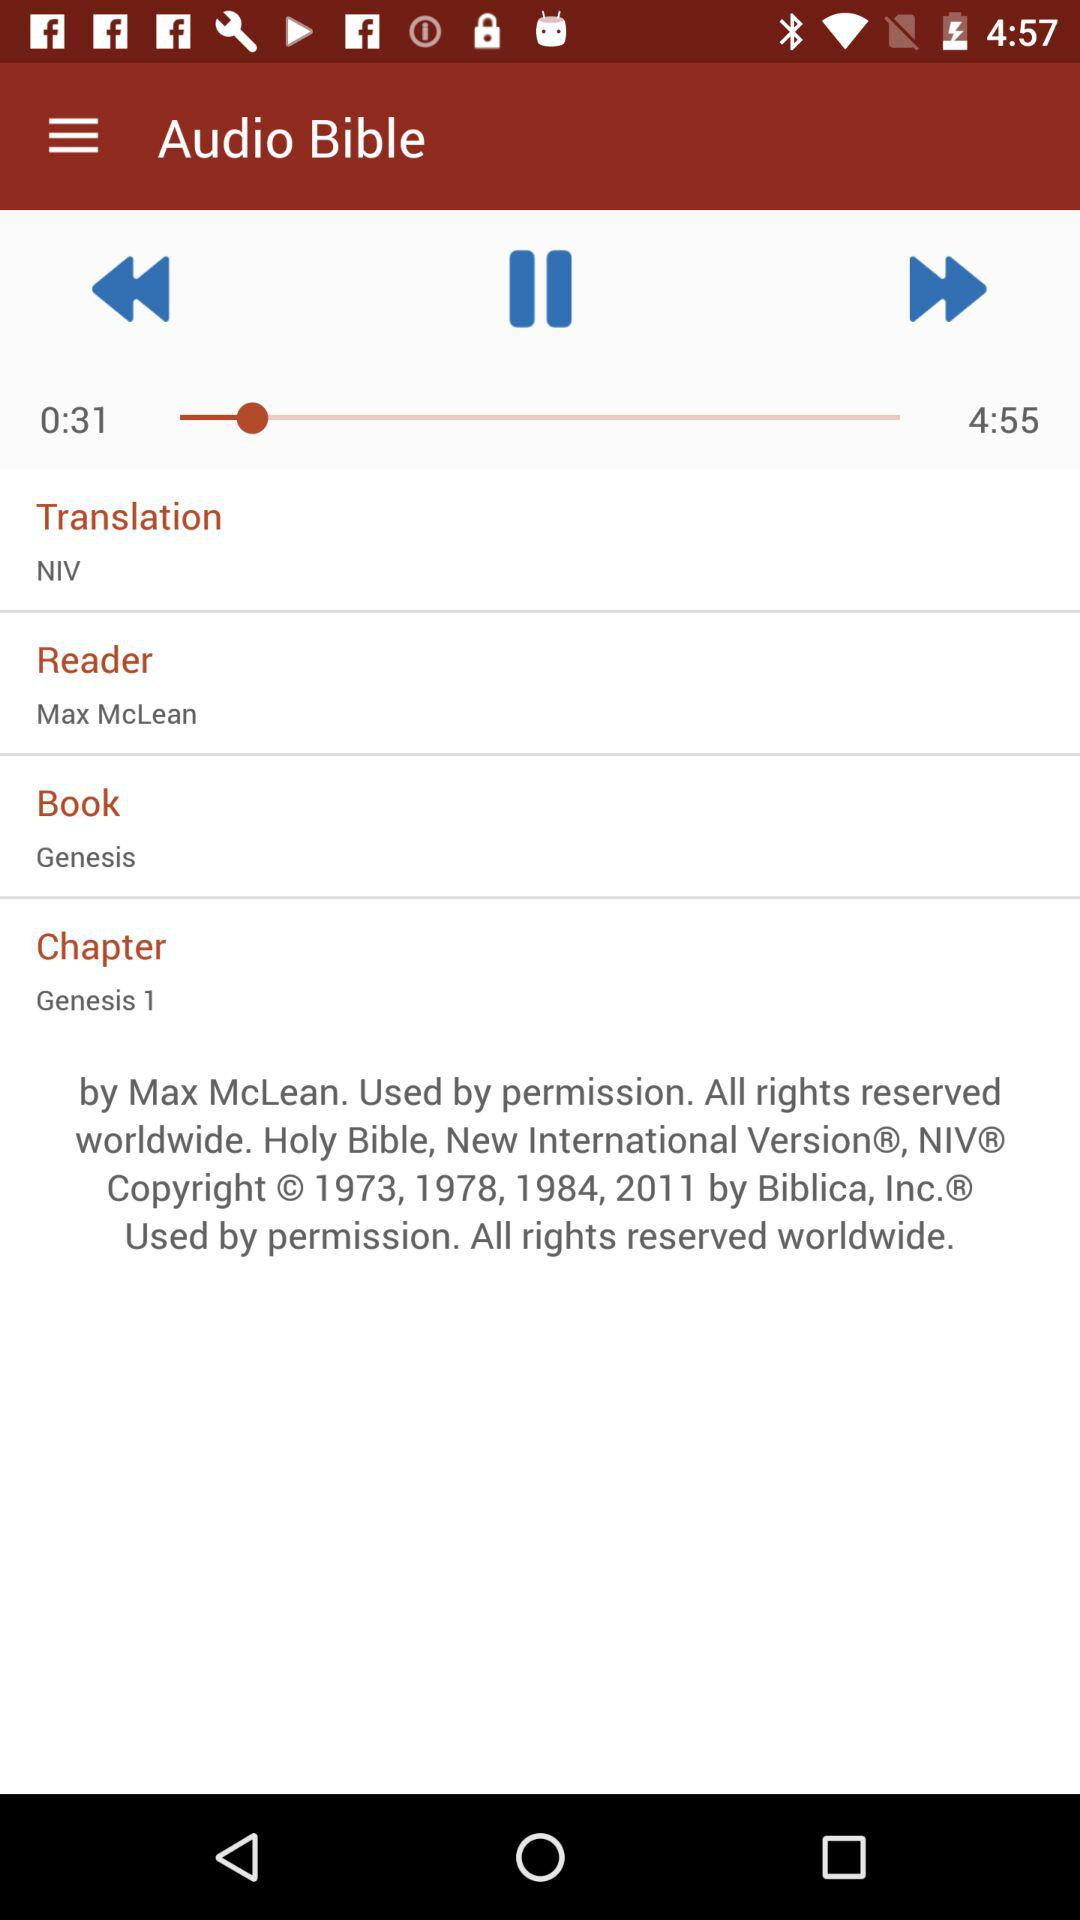What is the total duration of the audio? The total duration is 4:55. 